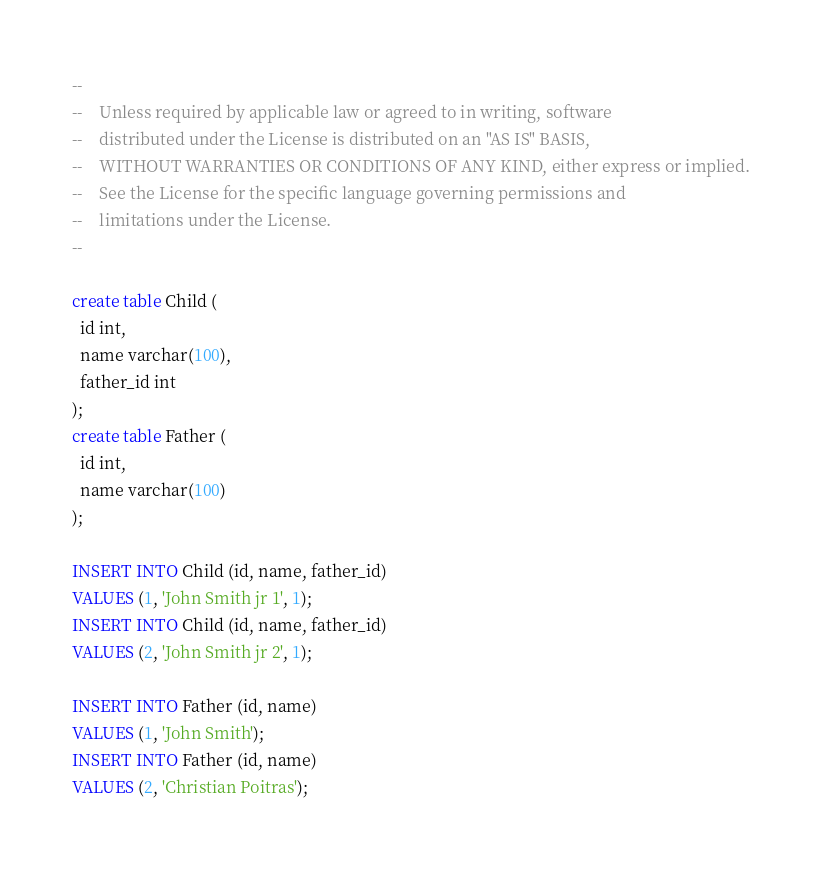Convert code to text. <code><loc_0><loc_0><loc_500><loc_500><_SQL_>--
--    Unless required by applicable law or agreed to in writing, software
--    distributed under the License is distributed on an "AS IS" BASIS,
--    WITHOUT WARRANTIES OR CONDITIONS OF ANY KIND, either express or implied.
--    See the License for the specific language governing permissions and
--    limitations under the License.
--

create table Child (
  id int,
  name varchar(100),
  father_id int
);
create table Father (
  id int,
  name varchar(100)
);

INSERT INTO Child (id, name, father_id)
VALUES (1, 'John Smith jr 1', 1);
INSERT INTO Child (id, name, father_id)
VALUES (2, 'John Smith jr 2', 1);

INSERT INTO Father (id, name)
VALUES (1, 'John Smith');
INSERT INTO Father (id, name)
VALUES (2, 'Christian Poitras');
</code> 